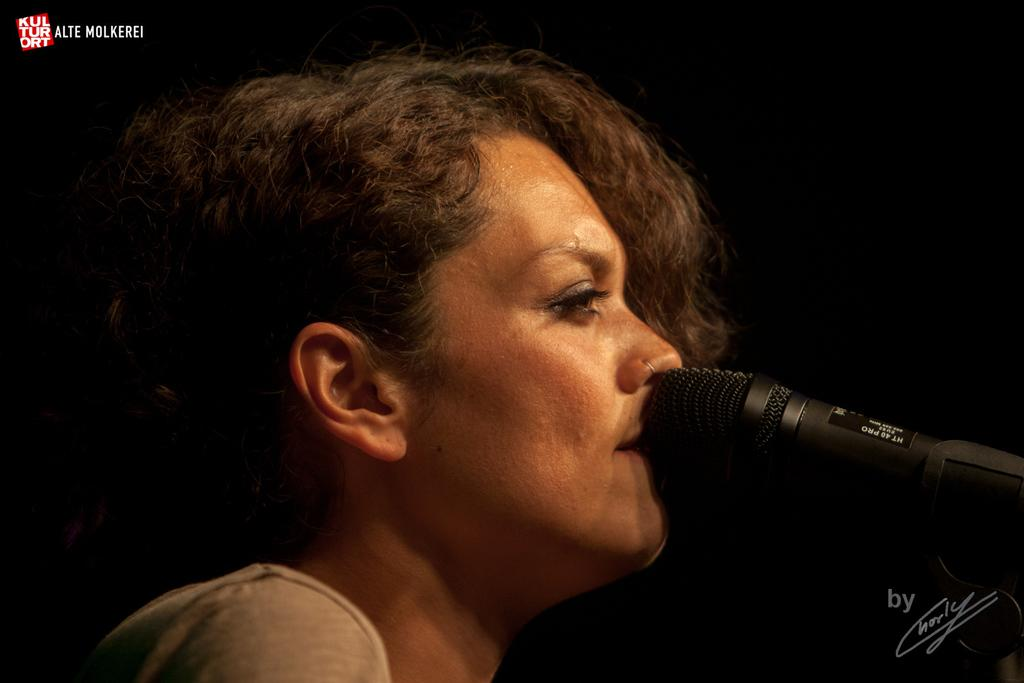Who is present in the image? There is a woman in the image. What object can be seen in the image? There is a mic in the image. What type of flowers can be seen in the garden in the image? There is no garden present in the image, so it is not possible to determine what type of flowers might be seen. 